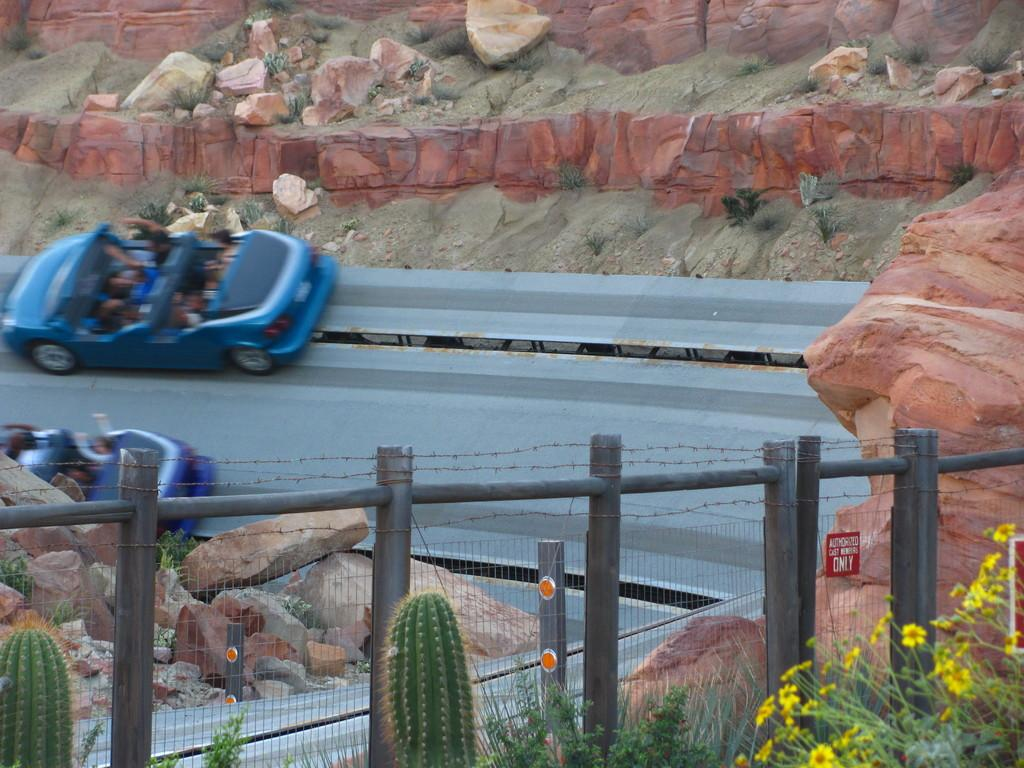What can be seen on the road in the image? There are two cars on the road in the image. What is located near the road in the image? There is a fence in the image. What type of vegetation is present in the image? There are plants in the right corner of the image. What type of sheet is covering the wilderness in the image? There is no wilderness or sheet present in the image. 